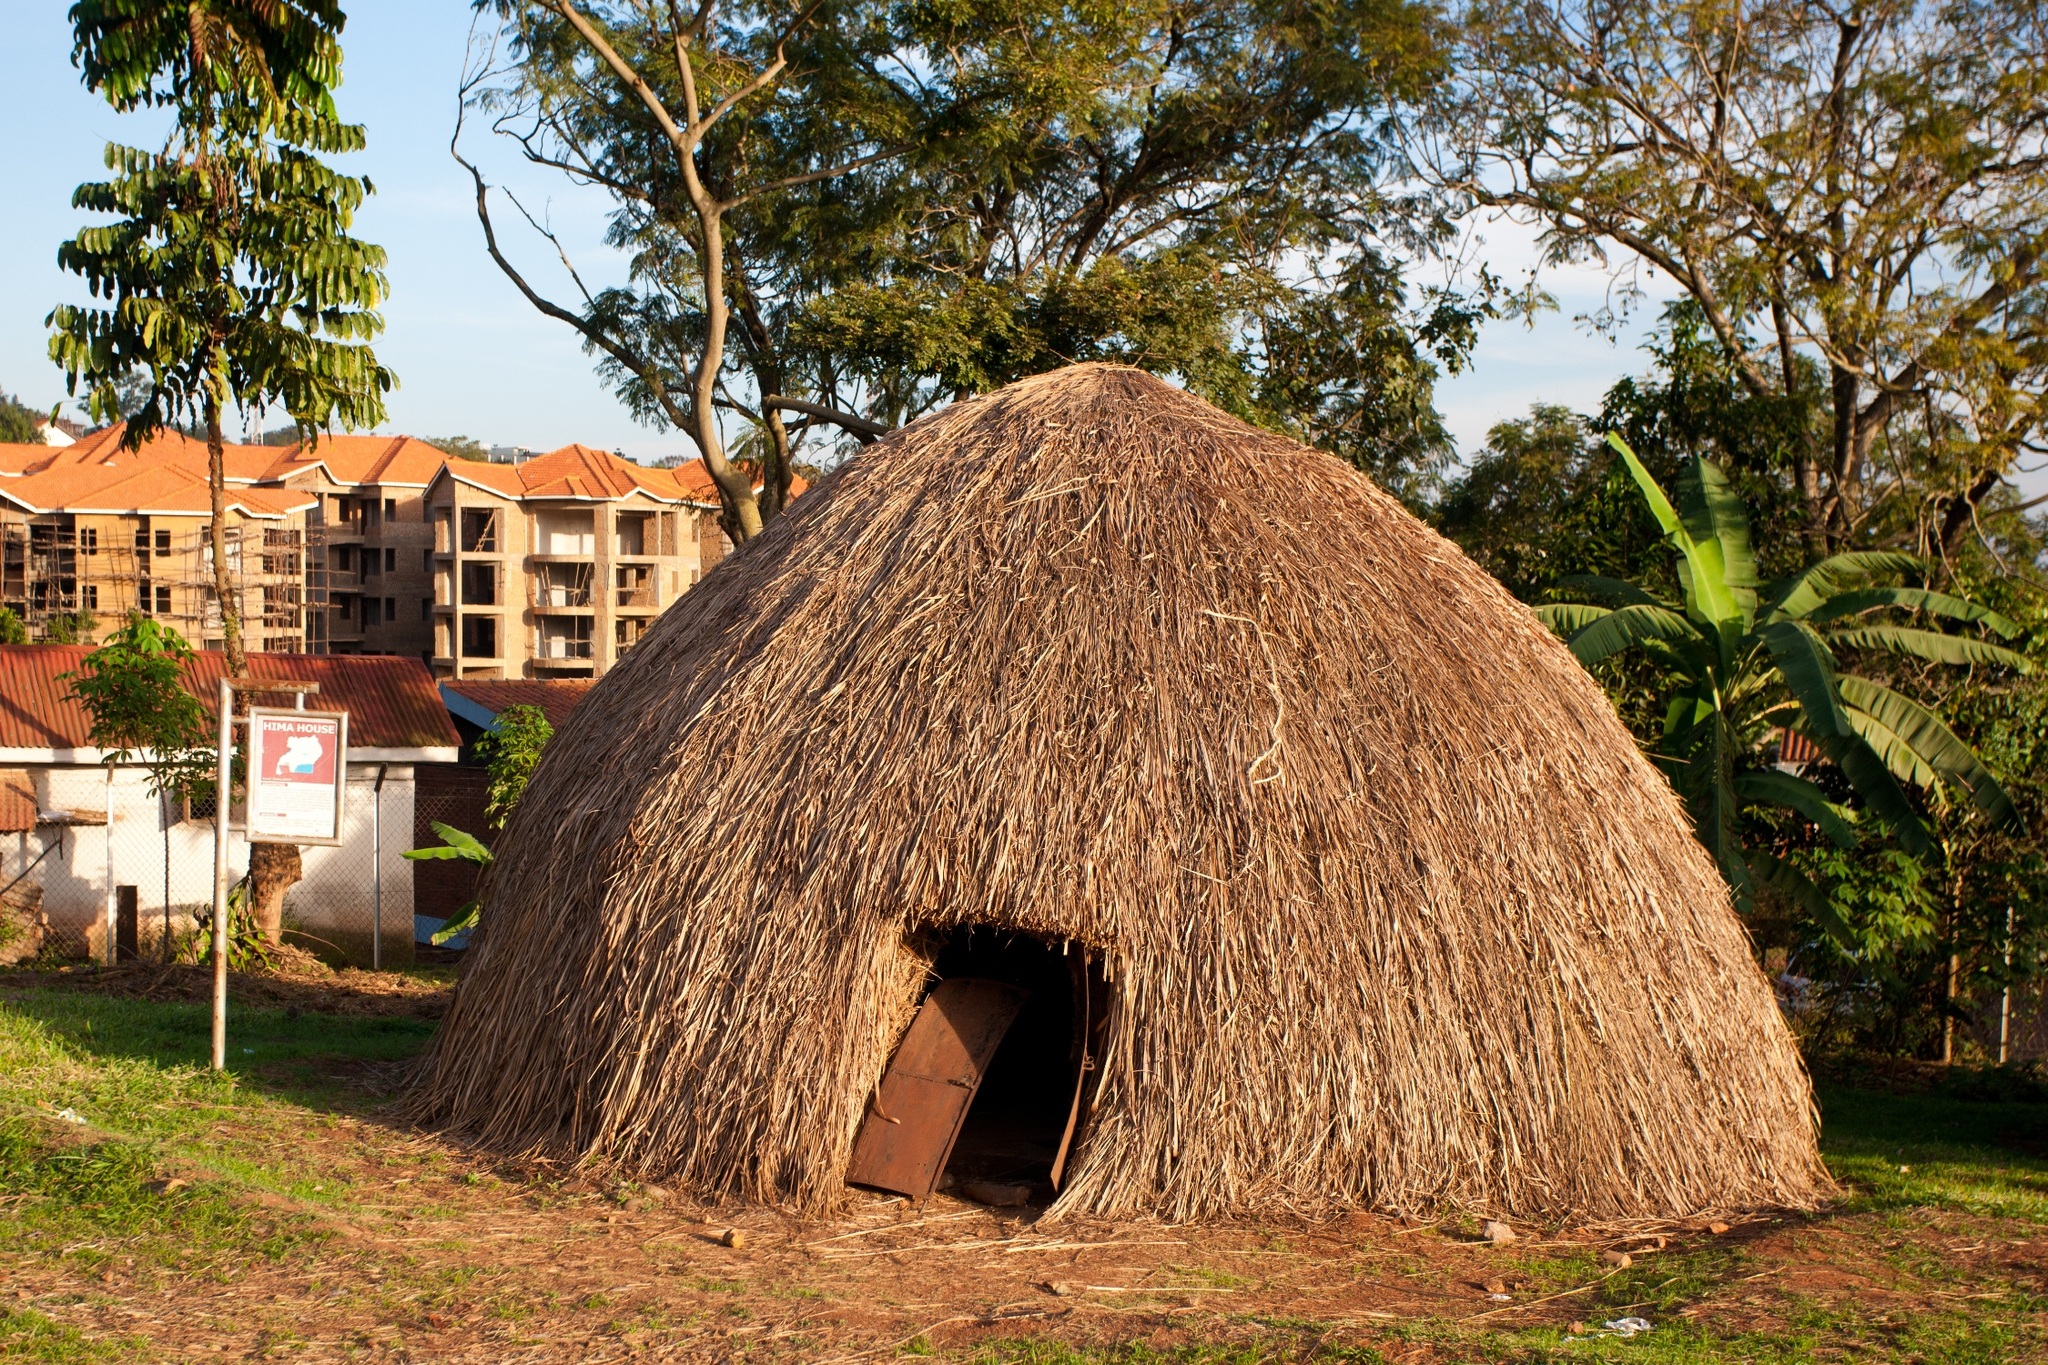Describe the contrast between the traditional hut and the modern buildings in the background. The contrast in the image is striking. On the one hand, the traditional hut, with its natural materials and design, represents a way of life that is closely connected to the land and its resources. On the other hand, the modern buildings in the background, with their geometric shapes and construction materials like concrete, represent the progress of urban development. This duality highlights the coexistence of the past and the still-developing present, each with distinct architectural and cultural implications. 